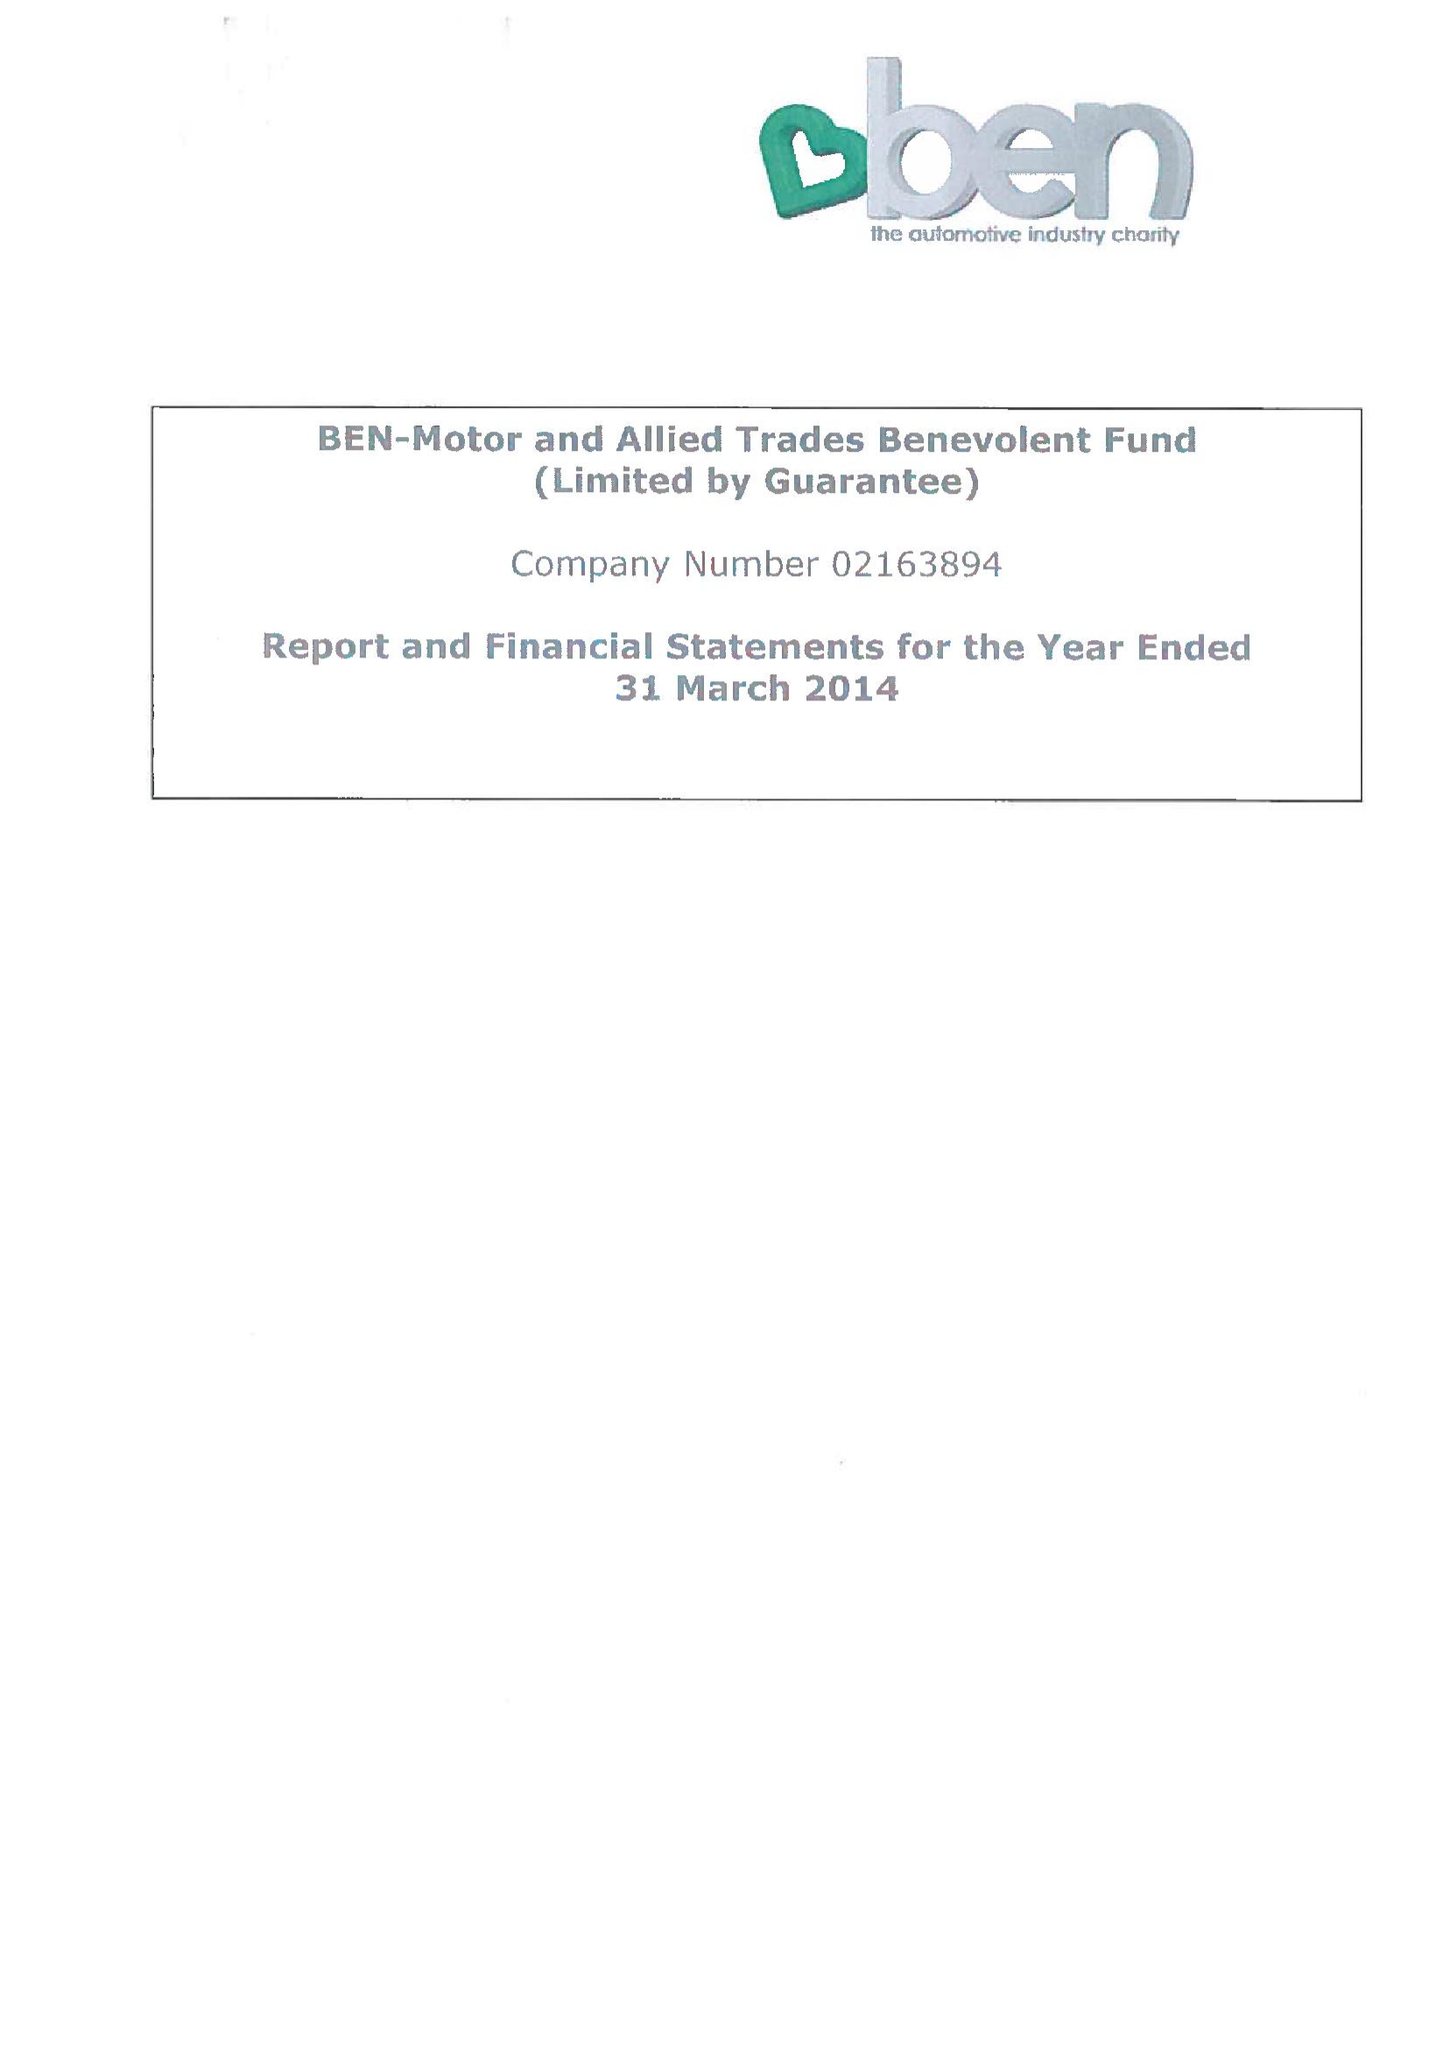What is the value for the address__postcode?
Answer the question using a single word or phrase. SL5 0AJ 